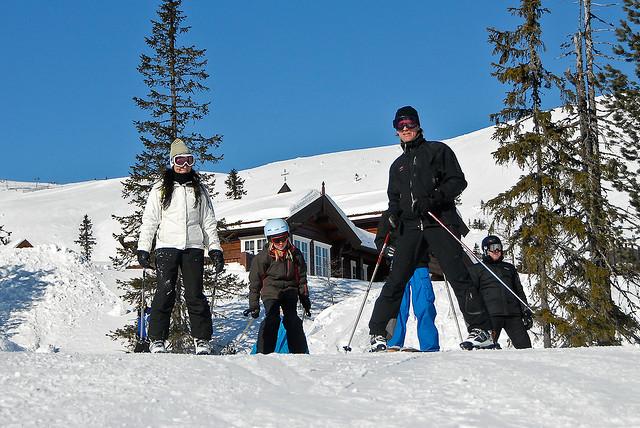What kind of weather is happening here?
Write a very short answer. Winter. What are the men wearing on their heads?
Write a very short answer. Hats. How many people are wearing black pants?
Give a very brief answer. 4. What are they about to do?
Give a very brief answer. Ski. 